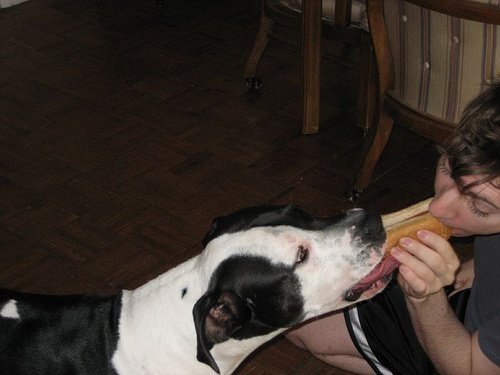Describe the objects in this image and their specific colors. I can see dog in gray, black, lightgray, and darkgray tones, people in gray, black, brown, and maroon tones, chair in gray and black tones, chair in gray and black tones, and hot dog in gray, brown, and tan tones in this image. 